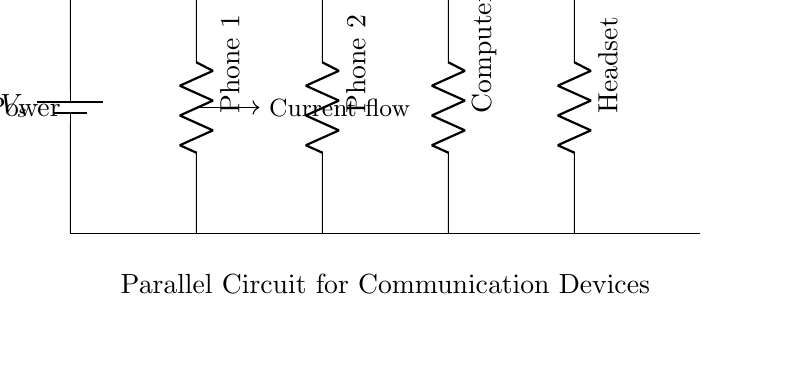What is the type of circuit shown? The circuit is a parallel circuit because multiple resistive elements (communication devices) are connected across the same two nodes. In this case, the devices are in parallel, allowing for independent operation and equal voltage across each device.
Answer: Parallel How many communication devices are in the circuit? There are four communication devices shown in the diagram: Phone 1, Phone 2, Computer, and Headset. Each device is represented as a resistor in parallel. The count is obtained by simply counting each labeled resistor.
Answer: Four What is the purpose of the battery in this circuit? The battery provides the supply voltage for the entire circuit, ensuring that each device receives the same potential difference across its terminals. This function is crucial as it powers all the connected communication devices simultaneously.
Answer: Power supply What happens to the current if one device fails? If one device fails (opens its circuit), the others will still function normally because they are in parallel. This is a key property of parallel circuits; the total current splits among the devices and will not be interrupted by a single failure.
Answer: Remains unchanged What is the voltage across each device? The voltage across each device is equal to the voltage of the power supply, denoted as V_s. In a parallel circuit, all components share the same voltage across their terminals, which is a defining characteristic of this circuit type.
Answer: V_s Which device is the most likely to draw the most current? The device that is likely to draw the most current is the one with the lowest resistance. The relationship between current, voltage, and resistance (from Ohm’s Law) indicates that current is inversely proportional to resistance. The actual current can be determined by the specific resistance values, which are not provided here.
Answer: Lowest resistance device What can you say about the overall resistance of the circuit? The overall resistance of a parallel circuit is less than the resistance of the smallest individual resistor. This is because the total current can flow through multiple paths, effectively reducing the equivalent resistance observed from the power supply's perspective.
Answer: Less than the smallest resistance 